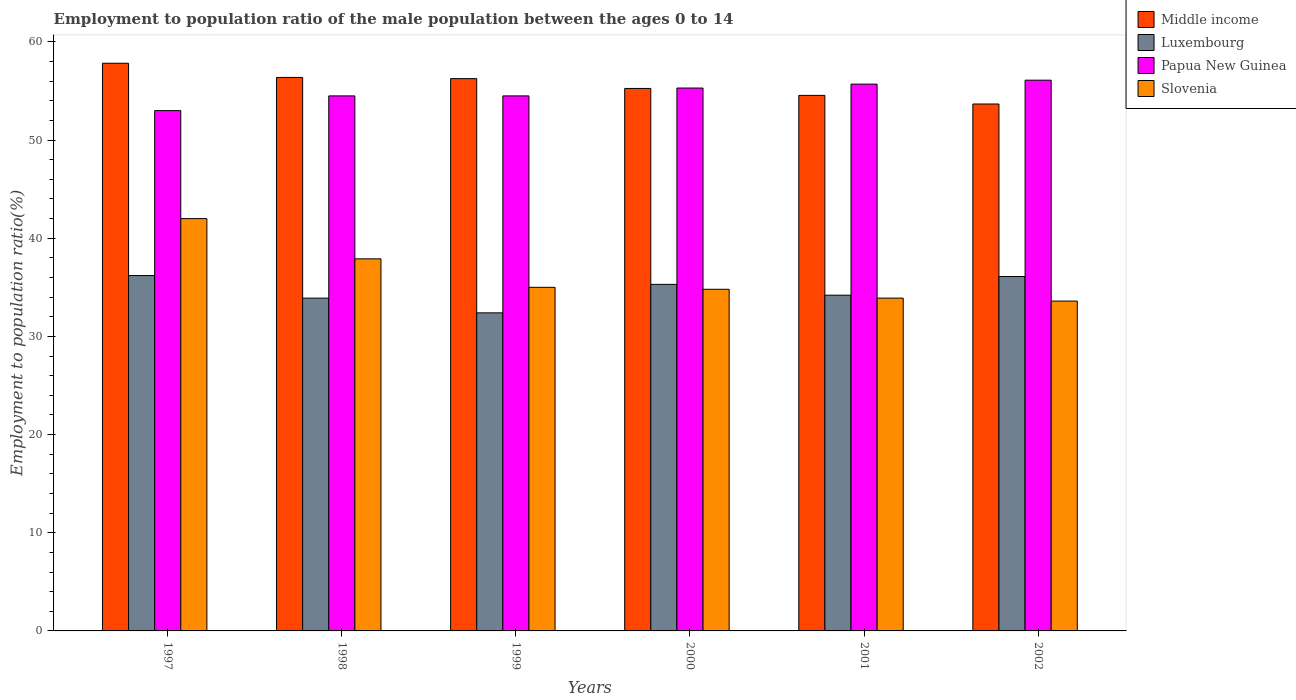How many different coloured bars are there?
Give a very brief answer. 4. How many groups of bars are there?
Make the answer very short. 6. Are the number of bars on each tick of the X-axis equal?
Give a very brief answer. Yes. What is the label of the 3rd group of bars from the left?
Offer a terse response. 1999. In how many cases, is the number of bars for a given year not equal to the number of legend labels?
Keep it short and to the point. 0. What is the employment to population ratio in Middle income in 2002?
Offer a very short reply. 53.67. Across all years, what is the minimum employment to population ratio in Papua New Guinea?
Your answer should be compact. 53. In which year was the employment to population ratio in Luxembourg maximum?
Ensure brevity in your answer.  1997. In which year was the employment to population ratio in Luxembourg minimum?
Keep it short and to the point. 1999. What is the total employment to population ratio in Slovenia in the graph?
Provide a short and direct response. 217.2. What is the difference between the employment to population ratio in Papua New Guinea in 1999 and that in 2000?
Make the answer very short. -0.8. What is the difference between the employment to population ratio in Middle income in 1998 and the employment to population ratio in Papua New Guinea in 2001?
Offer a very short reply. 0.68. What is the average employment to population ratio in Luxembourg per year?
Give a very brief answer. 34.68. In the year 1999, what is the difference between the employment to population ratio in Luxembourg and employment to population ratio in Papua New Guinea?
Make the answer very short. -22.1. What is the ratio of the employment to population ratio in Middle income in 1998 to that in 1999?
Keep it short and to the point. 1. Is the difference between the employment to population ratio in Luxembourg in 1997 and 2002 greater than the difference between the employment to population ratio in Papua New Guinea in 1997 and 2002?
Your answer should be very brief. Yes. What is the difference between the highest and the second highest employment to population ratio in Luxembourg?
Provide a succinct answer. 0.1. What is the difference between the highest and the lowest employment to population ratio in Middle income?
Offer a terse response. 4.15. In how many years, is the employment to population ratio in Slovenia greater than the average employment to population ratio in Slovenia taken over all years?
Your response must be concise. 2. Is the sum of the employment to population ratio in Middle income in 1997 and 2001 greater than the maximum employment to population ratio in Slovenia across all years?
Your answer should be very brief. Yes. What does the 3rd bar from the left in 2000 represents?
Ensure brevity in your answer.  Papua New Guinea. What does the 3rd bar from the right in 2002 represents?
Make the answer very short. Luxembourg. Is it the case that in every year, the sum of the employment to population ratio in Middle income and employment to population ratio in Papua New Guinea is greater than the employment to population ratio in Slovenia?
Provide a short and direct response. Yes. Are all the bars in the graph horizontal?
Your response must be concise. No. How many years are there in the graph?
Offer a very short reply. 6. Are the values on the major ticks of Y-axis written in scientific E-notation?
Your response must be concise. No. Does the graph contain grids?
Provide a succinct answer. No. Where does the legend appear in the graph?
Offer a terse response. Top right. What is the title of the graph?
Ensure brevity in your answer.  Employment to population ratio of the male population between the ages 0 to 14. What is the label or title of the X-axis?
Your response must be concise. Years. What is the Employment to population ratio(%) in Middle income in 1997?
Offer a very short reply. 57.82. What is the Employment to population ratio(%) of Luxembourg in 1997?
Keep it short and to the point. 36.2. What is the Employment to population ratio(%) of Papua New Guinea in 1997?
Your answer should be compact. 53. What is the Employment to population ratio(%) of Slovenia in 1997?
Offer a terse response. 42. What is the Employment to population ratio(%) of Middle income in 1998?
Your response must be concise. 56.38. What is the Employment to population ratio(%) in Luxembourg in 1998?
Your response must be concise. 33.9. What is the Employment to population ratio(%) in Papua New Guinea in 1998?
Provide a short and direct response. 54.5. What is the Employment to population ratio(%) of Slovenia in 1998?
Offer a very short reply. 37.9. What is the Employment to population ratio(%) of Middle income in 1999?
Offer a very short reply. 56.26. What is the Employment to population ratio(%) in Luxembourg in 1999?
Your answer should be compact. 32.4. What is the Employment to population ratio(%) in Papua New Guinea in 1999?
Offer a very short reply. 54.5. What is the Employment to population ratio(%) in Middle income in 2000?
Offer a terse response. 55.26. What is the Employment to population ratio(%) in Luxembourg in 2000?
Ensure brevity in your answer.  35.3. What is the Employment to population ratio(%) of Papua New Guinea in 2000?
Your answer should be very brief. 55.3. What is the Employment to population ratio(%) of Slovenia in 2000?
Make the answer very short. 34.8. What is the Employment to population ratio(%) in Middle income in 2001?
Your response must be concise. 54.55. What is the Employment to population ratio(%) in Luxembourg in 2001?
Provide a succinct answer. 34.2. What is the Employment to population ratio(%) of Papua New Guinea in 2001?
Your response must be concise. 55.7. What is the Employment to population ratio(%) of Slovenia in 2001?
Provide a succinct answer. 33.9. What is the Employment to population ratio(%) of Middle income in 2002?
Your answer should be very brief. 53.67. What is the Employment to population ratio(%) of Luxembourg in 2002?
Your response must be concise. 36.1. What is the Employment to population ratio(%) in Papua New Guinea in 2002?
Ensure brevity in your answer.  56.1. What is the Employment to population ratio(%) in Slovenia in 2002?
Keep it short and to the point. 33.6. Across all years, what is the maximum Employment to population ratio(%) in Middle income?
Keep it short and to the point. 57.82. Across all years, what is the maximum Employment to population ratio(%) of Luxembourg?
Give a very brief answer. 36.2. Across all years, what is the maximum Employment to population ratio(%) in Papua New Guinea?
Provide a short and direct response. 56.1. Across all years, what is the minimum Employment to population ratio(%) in Middle income?
Offer a terse response. 53.67. Across all years, what is the minimum Employment to population ratio(%) of Luxembourg?
Give a very brief answer. 32.4. Across all years, what is the minimum Employment to population ratio(%) of Papua New Guinea?
Make the answer very short. 53. Across all years, what is the minimum Employment to population ratio(%) in Slovenia?
Make the answer very short. 33.6. What is the total Employment to population ratio(%) in Middle income in the graph?
Provide a succinct answer. 333.94. What is the total Employment to population ratio(%) of Luxembourg in the graph?
Offer a terse response. 208.1. What is the total Employment to population ratio(%) in Papua New Guinea in the graph?
Make the answer very short. 329.1. What is the total Employment to population ratio(%) of Slovenia in the graph?
Offer a very short reply. 217.2. What is the difference between the Employment to population ratio(%) of Middle income in 1997 and that in 1998?
Your response must be concise. 1.45. What is the difference between the Employment to population ratio(%) in Luxembourg in 1997 and that in 1998?
Offer a terse response. 2.3. What is the difference between the Employment to population ratio(%) of Papua New Guinea in 1997 and that in 1998?
Give a very brief answer. -1.5. What is the difference between the Employment to population ratio(%) in Slovenia in 1997 and that in 1998?
Your answer should be compact. 4.1. What is the difference between the Employment to population ratio(%) of Middle income in 1997 and that in 1999?
Give a very brief answer. 1.57. What is the difference between the Employment to population ratio(%) of Luxembourg in 1997 and that in 1999?
Give a very brief answer. 3.8. What is the difference between the Employment to population ratio(%) of Papua New Guinea in 1997 and that in 1999?
Keep it short and to the point. -1.5. What is the difference between the Employment to population ratio(%) in Middle income in 1997 and that in 2000?
Your response must be concise. 2.57. What is the difference between the Employment to population ratio(%) in Luxembourg in 1997 and that in 2000?
Offer a very short reply. 0.9. What is the difference between the Employment to population ratio(%) of Papua New Guinea in 1997 and that in 2000?
Give a very brief answer. -2.3. What is the difference between the Employment to population ratio(%) of Slovenia in 1997 and that in 2000?
Your response must be concise. 7.2. What is the difference between the Employment to population ratio(%) of Middle income in 1997 and that in 2001?
Your response must be concise. 3.27. What is the difference between the Employment to population ratio(%) of Luxembourg in 1997 and that in 2001?
Provide a short and direct response. 2. What is the difference between the Employment to population ratio(%) of Papua New Guinea in 1997 and that in 2001?
Keep it short and to the point. -2.7. What is the difference between the Employment to population ratio(%) of Slovenia in 1997 and that in 2001?
Ensure brevity in your answer.  8.1. What is the difference between the Employment to population ratio(%) of Middle income in 1997 and that in 2002?
Your response must be concise. 4.15. What is the difference between the Employment to population ratio(%) of Luxembourg in 1997 and that in 2002?
Keep it short and to the point. 0.1. What is the difference between the Employment to population ratio(%) in Papua New Guinea in 1997 and that in 2002?
Your answer should be very brief. -3.1. What is the difference between the Employment to population ratio(%) in Slovenia in 1997 and that in 2002?
Give a very brief answer. 8.4. What is the difference between the Employment to population ratio(%) of Middle income in 1998 and that in 1999?
Your response must be concise. 0.12. What is the difference between the Employment to population ratio(%) in Luxembourg in 1998 and that in 1999?
Offer a very short reply. 1.5. What is the difference between the Employment to population ratio(%) of Papua New Guinea in 1998 and that in 1999?
Your response must be concise. 0. What is the difference between the Employment to population ratio(%) in Middle income in 1998 and that in 2000?
Offer a terse response. 1.12. What is the difference between the Employment to population ratio(%) in Luxembourg in 1998 and that in 2000?
Provide a succinct answer. -1.4. What is the difference between the Employment to population ratio(%) in Slovenia in 1998 and that in 2000?
Your response must be concise. 3.1. What is the difference between the Employment to population ratio(%) of Middle income in 1998 and that in 2001?
Offer a very short reply. 1.83. What is the difference between the Employment to population ratio(%) of Middle income in 1998 and that in 2002?
Provide a short and direct response. 2.71. What is the difference between the Employment to population ratio(%) in Middle income in 1999 and that in 2000?
Keep it short and to the point. 1. What is the difference between the Employment to population ratio(%) of Slovenia in 1999 and that in 2000?
Offer a very short reply. 0.2. What is the difference between the Employment to population ratio(%) of Middle income in 1999 and that in 2001?
Keep it short and to the point. 1.71. What is the difference between the Employment to population ratio(%) in Luxembourg in 1999 and that in 2001?
Ensure brevity in your answer.  -1.8. What is the difference between the Employment to population ratio(%) of Papua New Guinea in 1999 and that in 2001?
Offer a terse response. -1.2. What is the difference between the Employment to population ratio(%) in Slovenia in 1999 and that in 2001?
Offer a very short reply. 1.1. What is the difference between the Employment to population ratio(%) of Middle income in 1999 and that in 2002?
Your answer should be compact. 2.58. What is the difference between the Employment to population ratio(%) of Middle income in 2000 and that in 2001?
Your answer should be very brief. 0.71. What is the difference between the Employment to population ratio(%) of Luxembourg in 2000 and that in 2001?
Offer a very short reply. 1.1. What is the difference between the Employment to population ratio(%) in Papua New Guinea in 2000 and that in 2001?
Offer a terse response. -0.4. What is the difference between the Employment to population ratio(%) in Middle income in 2000 and that in 2002?
Provide a succinct answer. 1.59. What is the difference between the Employment to population ratio(%) of Luxembourg in 2000 and that in 2002?
Your answer should be compact. -0.8. What is the difference between the Employment to population ratio(%) of Papua New Guinea in 2000 and that in 2002?
Provide a succinct answer. -0.8. What is the difference between the Employment to population ratio(%) of Middle income in 2001 and that in 2002?
Provide a short and direct response. 0.88. What is the difference between the Employment to population ratio(%) in Slovenia in 2001 and that in 2002?
Provide a short and direct response. 0.3. What is the difference between the Employment to population ratio(%) in Middle income in 1997 and the Employment to population ratio(%) in Luxembourg in 1998?
Your answer should be very brief. 23.92. What is the difference between the Employment to population ratio(%) in Middle income in 1997 and the Employment to population ratio(%) in Papua New Guinea in 1998?
Your answer should be very brief. 3.32. What is the difference between the Employment to population ratio(%) in Middle income in 1997 and the Employment to population ratio(%) in Slovenia in 1998?
Keep it short and to the point. 19.92. What is the difference between the Employment to population ratio(%) of Luxembourg in 1997 and the Employment to population ratio(%) of Papua New Guinea in 1998?
Give a very brief answer. -18.3. What is the difference between the Employment to population ratio(%) of Luxembourg in 1997 and the Employment to population ratio(%) of Slovenia in 1998?
Your response must be concise. -1.7. What is the difference between the Employment to population ratio(%) in Papua New Guinea in 1997 and the Employment to population ratio(%) in Slovenia in 1998?
Offer a very short reply. 15.1. What is the difference between the Employment to population ratio(%) in Middle income in 1997 and the Employment to population ratio(%) in Luxembourg in 1999?
Provide a succinct answer. 25.42. What is the difference between the Employment to population ratio(%) of Middle income in 1997 and the Employment to population ratio(%) of Papua New Guinea in 1999?
Offer a terse response. 3.32. What is the difference between the Employment to population ratio(%) of Middle income in 1997 and the Employment to population ratio(%) of Slovenia in 1999?
Provide a short and direct response. 22.82. What is the difference between the Employment to population ratio(%) of Luxembourg in 1997 and the Employment to population ratio(%) of Papua New Guinea in 1999?
Your answer should be very brief. -18.3. What is the difference between the Employment to population ratio(%) of Luxembourg in 1997 and the Employment to population ratio(%) of Slovenia in 1999?
Offer a terse response. 1.2. What is the difference between the Employment to population ratio(%) of Papua New Guinea in 1997 and the Employment to population ratio(%) of Slovenia in 1999?
Your answer should be very brief. 18. What is the difference between the Employment to population ratio(%) in Middle income in 1997 and the Employment to population ratio(%) in Luxembourg in 2000?
Offer a very short reply. 22.52. What is the difference between the Employment to population ratio(%) in Middle income in 1997 and the Employment to population ratio(%) in Papua New Guinea in 2000?
Provide a short and direct response. 2.52. What is the difference between the Employment to population ratio(%) in Middle income in 1997 and the Employment to population ratio(%) in Slovenia in 2000?
Make the answer very short. 23.02. What is the difference between the Employment to population ratio(%) of Luxembourg in 1997 and the Employment to population ratio(%) of Papua New Guinea in 2000?
Your response must be concise. -19.1. What is the difference between the Employment to population ratio(%) in Luxembourg in 1997 and the Employment to population ratio(%) in Slovenia in 2000?
Offer a terse response. 1.4. What is the difference between the Employment to population ratio(%) of Middle income in 1997 and the Employment to population ratio(%) of Luxembourg in 2001?
Your response must be concise. 23.62. What is the difference between the Employment to population ratio(%) of Middle income in 1997 and the Employment to population ratio(%) of Papua New Guinea in 2001?
Provide a short and direct response. 2.12. What is the difference between the Employment to population ratio(%) in Middle income in 1997 and the Employment to population ratio(%) in Slovenia in 2001?
Ensure brevity in your answer.  23.92. What is the difference between the Employment to population ratio(%) in Luxembourg in 1997 and the Employment to population ratio(%) in Papua New Guinea in 2001?
Ensure brevity in your answer.  -19.5. What is the difference between the Employment to population ratio(%) in Middle income in 1997 and the Employment to population ratio(%) in Luxembourg in 2002?
Keep it short and to the point. 21.72. What is the difference between the Employment to population ratio(%) of Middle income in 1997 and the Employment to population ratio(%) of Papua New Guinea in 2002?
Your response must be concise. 1.72. What is the difference between the Employment to population ratio(%) of Middle income in 1997 and the Employment to population ratio(%) of Slovenia in 2002?
Make the answer very short. 24.22. What is the difference between the Employment to population ratio(%) in Luxembourg in 1997 and the Employment to population ratio(%) in Papua New Guinea in 2002?
Make the answer very short. -19.9. What is the difference between the Employment to population ratio(%) in Luxembourg in 1997 and the Employment to population ratio(%) in Slovenia in 2002?
Offer a terse response. 2.6. What is the difference between the Employment to population ratio(%) in Papua New Guinea in 1997 and the Employment to population ratio(%) in Slovenia in 2002?
Your answer should be compact. 19.4. What is the difference between the Employment to population ratio(%) of Middle income in 1998 and the Employment to population ratio(%) of Luxembourg in 1999?
Ensure brevity in your answer.  23.98. What is the difference between the Employment to population ratio(%) in Middle income in 1998 and the Employment to population ratio(%) in Papua New Guinea in 1999?
Keep it short and to the point. 1.88. What is the difference between the Employment to population ratio(%) of Middle income in 1998 and the Employment to population ratio(%) of Slovenia in 1999?
Provide a succinct answer. 21.38. What is the difference between the Employment to population ratio(%) of Luxembourg in 1998 and the Employment to population ratio(%) of Papua New Guinea in 1999?
Make the answer very short. -20.6. What is the difference between the Employment to population ratio(%) of Luxembourg in 1998 and the Employment to population ratio(%) of Slovenia in 1999?
Ensure brevity in your answer.  -1.1. What is the difference between the Employment to population ratio(%) of Papua New Guinea in 1998 and the Employment to population ratio(%) of Slovenia in 1999?
Ensure brevity in your answer.  19.5. What is the difference between the Employment to population ratio(%) of Middle income in 1998 and the Employment to population ratio(%) of Luxembourg in 2000?
Provide a short and direct response. 21.08. What is the difference between the Employment to population ratio(%) in Middle income in 1998 and the Employment to population ratio(%) in Papua New Guinea in 2000?
Provide a short and direct response. 1.08. What is the difference between the Employment to population ratio(%) of Middle income in 1998 and the Employment to population ratio(%) of Slovenia in 2000?
Keep it short and to the point. 21.58. What is the difference between the Employment to population ratio(%) in Luxembourg in 1998 and the Employment to population ratio(%) in Papua New Guinea in 2000?
Provide a succinct answer. -21.4. What is the difference between the Employment to population ratio(%) of Luxembourg in 1998 and the Employment to population ratio(%) of Slovenia in 2000?
Offer a very short reply. -0.9. What is the difference between the Employment to population ratio(%) of Middle income in 1998 and the Employment to population ratio(%) of Luxembourg in 2001?
Your response must be concise. 22.18. What is the difference between the Employment to population ratio(%) of Middle income in 1998 and the Employment to population ratio(%) of Papua New Guinea in 2001?
Give a very brief answer. 0.68. What is the difference between the Employment to population ratio(%) of Middle income in 1998 and the Employment to population ratio(%) of Slovenia in 2001?
Ensure brevity in your answer.  22.48. What is the difference between the Employment to population ratio(%) in Luxembourg in 1998 and the Employment to population ratio(%) in Papua New Guinea in 2001?
Provide a short and direct response. -21.8. What is the difference between the Employment to population ratio(%) of Papua New Guinea in 1998 and the Employment to population ratio(%) of Slovenia in 2001?
Offer a very short reply. 20.6. What is the difference between the Employment to population ratio(%) of Middle income in 1998 and the Employment to population ratio(%) of Luxembourg in 2002?
Offer a terse response. 20.28. What is the difference between the Employment to population ratio(%) of Middle income in 1998 and the Employment to population ratio(%) of Papua New Guinea in 2002?
Provide a succinct answer. 0.28. What is the difference between the Employment to population ratio(%) of Middle income in 1998 and the Employment to population ratio(%) of Slovenia in 2002?
Offer a terse response. 22.78. What is the difference between the Employment to population ratio(%) in Luxembourg in 1998 and the Employment to population ratio(%) in Papua New Guinea in 2002?
Keep it short and to the point. -22.2. What is the difference between the Employment to population ratio(%) of Papua New Guinea in 1998 and the Employment to population ratio(%) of Slovenia in 2002?
Keep it short and to the point. 20.9. What is the difference between the Employment to population ratio(%) in Middle income in 1999 and the Employment to population ratio(%) in Luxembourg in 2000?
Ensure brevity in your answer.  20.96. What is the difference between the Employment to population ratio(%) of Middle income in 1999 and the Employment to population ratio(%) of Papua New Guinea in 2000?
Provide a succinct answer. 0.96. What is the difference between the Employment to population ratio(%) in Middle income in 1999 and the Employment to population ratio(%) in Slovenia in 2000?
Offer a very short reply. 21.46. What is the difference between the Employment to population ratio(%) in Luxembourg in 1999 and the Employment to population ratio(%) in Papua New Guinea in 2000?
Ensure brevity in your answer.  -22.9. What is the difference between the Employment to population ratio(%) in Luxembourg in 1999 and the Employment to population ratio(%) in Slovenia in 2000?
Offer a very short reply. -2.4. What is the difference between the Employment to population ratio(%) of Middle income in 1999 and the Employment to population ratio(%) of Luxembourg in 2001?
Your answer should be compact. 22.06. What is the difference between the Employment to population ratio(%) of Middle income in 1999 and the Employment to population ratio(%) of Papua New Guinea in 2001?
Make the answer very short. 0.56. What is the difference between the Employment to population ratio(%) in Middle income in 1999 and the Employment to population ratio(%) in Slovenia in 2001?
Offer a very short reply. 22.36. What is the difference between the Employment to population ratio(%) in Luxembourg in 1999 and the Employment to population ratio(%) in Papua New Guinea in 2001?
Offer a terse response. -23.3. What is the difference between the Employment to population ratio(%) of Luxembourg in 1999 and the Employment to population ratio(%) of Slovenia in 2001?
Offer a terse response. -1.5. What is the difference between the Employment to population ratio(%) of Papua New Guinea in 1999 and the Employment to population ratio(%) of Slovenia in 2001?
Your response must be concise. 20.6. What is the difference between the Employment to population ratio(%) in Middle income in 1999 and the Employment to population ratio(%) in Luxembourg in 2002?
Give a very brief answer. 20.16. What is the difference between the Employment to population ratio(%) in Middle income in 1999 and the Employment to population ratio(%) in Papua New Guinea in 2002?
Provide a short and direct response. 0.16. What is the difference between the Employment to population ratio(%) in Middle income in 1999 and the Employment to population ratio(%) in Slovenia in 2002?
Your answer should be compact. 22.66. What is the difference between the Employment to population ratio(%) in Luxembourg in 1999 and the Employment to population ratio(%) in Papua New Guinea in 2002?
Give a very brief answer. -23.7. What is the difference between the Employment to population ratio(%) in Papua New Guinea in 1999 and the Employment to population ratio(%) in Slovenia in 2002?
Make the answer very short. 20.9. What is the difference between the Employment to population ratio(%) of Middle income in 2000 and the Employment to population ratio(%) of Luxembourg in 2001?
Provide a succinct answer. 21.06. What is the difference between the Employment to population ratio(%) in Middle income in 2000 and the Employment to population ratio(%) in Papua New Guinea in 2001?
Ensure brevity in your answer.  -0.44. What is the difference between the Employment to population ratio(%) in Middle income in 2000 and the Employment to population ratio(%) in Slovenia in 2001?
Your answer should be compact. 21.36. What is the difference between the Employment to population ratio(%) of Luxembourg in 2000 and the Employment to population ratio(%) of Papua New Guinea in 2001?
Your answer should be very brief. -20.4. What is the difference between the Employment to population ratio(%) in Papua New Guinea in 2000 and the Employment to population ratio(%) in Slovenia in 2001?
Offer a terse response. 21.4. What is the difference between the Employment to population ratio(%) of Middle income in 2000 and the Employment to population ratio(%) of Luxembourg in 2002?
Give a very brief answer. 19.16. What is the difference between the Employment to population ratio(%) of Middle income in 2000 and the Employment to population ratio(%) of Papua New Guinea in 2002?
Your response must be concise. -0.84. What is the difference between the Employment to population ratio(%) of Middle income in 2000 and the Employment to population ratio(%) of Slovenia in 2002?
Make the answer very short. 21.66. What is the difference between the Employment to population ratio(%) in Luxembourg in 2000 and the Employment to population ratio(%) in Papua New Guinea in 2002?
Give a very brief answer. -20.8. What is the difference between the Employment to population ratio(%) of Papua New Guinea in 2000 and the Employment to population ratio(%) of Slovenia in 2002?
Provide a succinct answer. 21.7. What is the difference between the Employment to population ratio(%) of Middle income in 2001 and the Employment to population ratio(%) of Luxembourg in 2002?
Provide a short and direct response. 18.45. What is the difference between the Employment to population ratio(%) of Middle income in 2001 and the Employment to population ratio(%) of Papua New Guinea in 2002?
Your answer should be very brief. -1.55. What is the difference between the Employment to population ratio(%) of Middle income in 2001 and the Employment to population ratio(%) of Slovenia in 2002?
Your response must be concise. 20.95. What is the difference between the Employment to population ratio(%) of Luxembourg in 2001 and the Employment to population ratio(%) of Papua New Guinea in 2002?
Offer a very short reply. -21.9. What is the difference between the Employment to population ratio(%) of Luxembourg in 2001 and the Employment to population ratio(%) of Slovenia in 2002?
Ensure brevity in your answer.  0.6. What is the difference between the Employment to population ratio(%) of Papua New Guinea in 2001 and the Employment to population ratio(%) of Slovenia in 2002?
Your response must be concise. 22.1. What is the average Employment to population ratio(%) of Middle income per year?
Provide a succinct answer. 55.66. What is the average Employment to population ratio(%) of Luxembourg per year?
Make the answer very short. 34.68. What is the average Employment to population ratio(%) in Papua New Guinea per year?
Ensure brevity in your answer.  54.85. What is the average Employment to population ratio(%) in Slovenia per year?
Keep it short and to the point. 36.2. In the year 1997, what is the difference between the Employment to population ratio(%) of Middle income and Employment to population ratio(%) of Luxembourg?
Provide a short and direct response. 21.62. In the year 1997, what is the difference between the Employment to population ratio(%) of Middle income and Employment to population ratio(%) of Papua New Guinea?
Offer a terse response. 4.82. In the year 1997, what is the difference between the Employment to population ratio(%) of Middle income and Employment to population ratio(%) of Slovenia?
Keep it short and to the point. 15.82. In the year 1997, what is the difference between the Employment to population ratio(%) of Luxembourg and Employment to population ratio(%) of Papua New Guinea?
Offer a very short reply. -16.8. In the year 1997, what is the difference between the Employment to population ratio(%) in Papua New Guinea and Employment to population ratio(%) in Slovenia?
Make the answer very short. 11. In the year 1998, what is the difference between the Employment to population ratio(%) in Middle income and Employment to population ratio(%) in Luxembourg?
Ensure brevity in your answer.  22.48. In the year 1998, what is the difference between the Employment to population ratio(%) of Middle income and Employment to population ratio(%) of Papua New Guinea?
Your response must be concise. 1.88. In the year 1998, what is the difference between the Employment to population ratio(%) of Middle income and Employment to population ratio(%) of Slovenia?
Keep it short and to the point. 18.48. In the year 1998, what is the difference between the Employment to population ratio(%) of Luxembourg and Employment to population ratio(%) of Papua New Guinea?
Keep it short and to the point. -20.6. In the year 1998, what is the difference between the Employment to population ratio(%) in Luxembourg and Employment to population ratio(%) in Slovenia?
Ensure brevity in your answer.  -4. In the year 1999, what is the difference between the Employment to population ratio(%) in Middle income and Employment to population ratio(%) in Luxembourg?
Keep it short and to the point. 23.86. In the year 1999, what is the difference between the Employment to population ratio(%) in Middle income and Employment to population ratio(%) in Papua New Guinea?
Make the answer very short. 1.76. In the year 1999, what is the difference between the Employment to population ratio(%) of Middle income and Employment to population ratio(%) of Slovenia?
Provide a short and direct response. 21.26. In the year 1999, what is the difference between the Employment to population ratio(%) of Luxembourg and Employment to population ratio(%) of Papua New Guinea?
Your answer should be compact. -22.1. In the year 1999, what is the difference between the Employment to population ratio(%) of Papua New Guinea and Employment to population ratio(%) of Slovenia?
Make the answer very short. 19.5. In the year 2000, what is the difference between the Employment to population ratio(%) of Middle income and Employment to population ratio(%) of Luxembourg?
Offer a very short reply. 19.96. In the year 2000, what is the difference between the Employment to population ratio(%) of Middle income and Employment to population ratio(%) of Papua New Guinea?
Your answer should be very brief. -0.04. In the year 2000, what is the difference between the Employment to population ratio(%) of Middle income and Employment to population ratio(%) of Slovenia?
Keep it short and to the point. 20.46. In the year 2000, what is the difference between the Employment to population ratio(%) in Luxembourg and Employment to population ratio(%) in Papua New Guinea?
Keep it short and to the point. -20. In the year 2000, what is the difference between the Employment to population ratio(%) of Papua New Guinea and Employment to population ratio(%) of Slovenia?
Keep it short and to the point. 20.5. In the year 2001, what is the difference between the Employment to population ratio(%) in Middle income and Employment to population ratio(%) in Luxembourg?
Give a very brief answer. 20.35. In the year 2001, what is the difference between the Employment to population ratio(%) of Middle income and Employment to population ratio(%) of Papua New Guinea?
Give a very brief answer. -1.15. In the year 2001, what is the difference between the Employment to population ratio(%) of Middle income and Employment to population ratio(%) of Slovenia?
Provide a succinct answer. 20.65. In the year 2001, what is the difference between the Employment to population ratio(%) of Luxembourg and Employment to population ratio(%) of Papua New Guinea?
Provide a short and direct response. -21.5. In the year 2001, what is the difference between the Employment to population ratio(%) of Papua New Guinea and Employment to population ratio(%) of Slovenia?
Your answer should be compact. 21.8. In the year 2002, what is the difference between the Employment to population ratio(%) in Middle income and Employment to population ratio(%) in Luxembourg?
Make the answer very short. 17.57. In the year 2002, what is the difference between the Employment to population ratio(%) in Middle income and Employment to population ratio(%) in Papua New Guinea?
Provide a succinct answer. -2.43. In the year 2002, what is the difference between the Employment to population ratio(%) of Middle income and Employment to population ratio(%) of Slovenia?
Your answer should be very brief. 20.07. In the year 2002, what is the difference between the Employment to population ratio(%) of Luxembourg and Employment to population ratio(%) of Papua New Guinea?
Your answer should be very brief. -20. In the year 2002, what is the difference between the Employment to population ratio(%) in Luxembourg and Employment to population ratio(%) in Slovenia?
Offer a terse response. 2.5. In the year 2002, what is the difference between the Employment to population ratio(%) in Papua New Guinea and Employment to population ratio(%) in Slovenia?
Offer a terse response. 22.5. What is the ratio of the Employment to population ratio(%) in Middle income in 1997 to that in 1998?
Offer a very short reply. 1.03. What is the ratio of the Employment to population ratio(%) in Luxembourg in 1997 to that in 1998?
Offer a very short reply. 1.07. What is the ratio of the Employment to population ratio(%) of Papua New Guinea in 1997 to that in 1998?
Your response must be concise. 0.97. What is the ratio of the Employment to population ratio(%) of Slovenia in 1997 to that in 1998?
Your response must be concise. 1.11. What is the ratio of the Employment to population ratio(%) in Middle income in 1997 to that in 1999?
Provide a succinct answer. 1.03. What is the ratio of the Employment to population ratio(%) of Luxembourg in 1997 to that in 1999?
Your response must be concise. 1.12. What is the ratio of the Employment to population ratio(%) of Papua New Guinea in 1997 to that in 1999?
Provide a short and direct response. 0.97. What is the ratio of the Employment to population ratio(%) in Slovenia in 1997 to that in 1999?
Give a very brief answer. 1.2. What is the ratio of the Employment to population ratio(%) in Middle income in 1997 to that in 2000?
Make the answer very short. 1.05. What is the ratio of the Employment to population ratio(%) in Luxembourg in 1997 to that in 2000?
Provide a short and direct response. 1.03. What is the ratio of the Employment to population ratio(%) of Papua New Guinea in 1997 to that in 2000?
Make the answer very short. 0.96. What is the ratio of the Employment to population ratio(%) in Slovenia in 1997 to that in 2000?
Provide a succinct answer. 1.21. What is the ratio of the Employment to population ratio(%) of Middle income in 1997 to that in 2001?
Provide a short and direct response. 1.06. What is the ratio of the Employment to population ratio(%) in Luxembourg in 1997 to that in 2001?
Offer a very short reply. 1.06. What is the ratio of the Employment to population ratio(%) in Papua New Guinea in 1997 to that in 2001?
Ensure brevity in your answer.  0.95. What is the ratio of the Employment to population ratio(%) in Slovenia in 1997 to that in 2001?
Your response must be concise. 1.24. What is the ratio of the Employment to population ratio(%) in Middle income in 1997 to that in 2002?
Your answer should be very brief. 1.08. What is the ratio of the Employment to population ratio(%) of Papua New Guinea in 1997 to that in 2002?
Ensure brevity in your answer.  0.94. What is the ratio of the Employment to population ratio(%) in Luxembourg in 1998 to that in 1999?
Make the answer very short. 1.05. What is the ratio of the Employment to population ratio(%) of Slovenia in 1998 to that in 1999?
Your response must be concise. 1.08. What is the ratio of the Employment to population ratio(%) in Middle income in 1998 to that in 2000?
Ensure brevity in your answer.  1.02. What is the ratio of the Employment to population ratio(%) in Luxembourg in 1998 to that in 2000?
Provide a succinct answer. 0.96. What is the ratio of the Employment to population ratio(%) of Papua New Guinea in 1998 to that in 2000?
Provide a short and direct response. 0.99. What is the ratio of the Employment to population ratio(%) in Slovenia in 1998 to that in 2000?
Your answer should be compact. 1.09. What is the ratio of the Employment to population ratio(%) of Middle income in 1998 to that in 2001?
Ensure brevity in your answer.  1.03. What is the ratio of the Employment to population ratio(%) of Papua New Guinea in 1998 to that in 2001?
Your response must be concise. 0.98. What is the ratio of the Employment to population ratio(%) of Slovenia in 1998 to that in 2001?
Offer a terse response. 1.12. What is the ratio of the Employment to population ratio(%) of Middle income in 1998 to that in 2002?
Offer a very short reply. 1.05. What is the ratio of the Employment to population ratio(%) in Luxembourg in 1998 to that in 2002?
Offer a terse response. 0.94. What is the ratio of the Employment to population ratio(%) of Papua New Guinea in 1998 to that in 2002?
Your answer should be compact. 0.97. What is the ratio of the Employment to population ratio(%) of Slovenia in 1998 to that in 2002?
Provide a short and direct response. 1.13. What is the ratio of the Employment to population ratio(%) of Middle income in 1999 to that in 2000?
Give a very brief answer. 1.02. What is the ratio of the Employment to population ratio(%) of Luxembourg in 1999 to that in 2000?
Keep it short and to the point. 0.92. What is the ratio of the Employment to population ratio(%) in Papua New Guinea in 1999 to that in 2000?
Ensure brevity in your answer.  0.99. What is the ratio of the Employment to population ratio(%) in Slovenia in 1999 to that in 2000?
Your response must be concise. 1.01. What is the ratio of the Employment to population ratio(%) of Middle income in 1999 to that in 2001?
Your answer should be compact. 1.03. What is the ratio of the Employment to population ratio(%) of Papua New Guinea in 1999 to that in 2001?
Offer a very short reply. 0.98. What is the ratio of the Employment to population ratio(%) of Slovenia in 1999 to that in 2001?
Your answer should be very brief. 1.03. What is the ratio of the Employment to population ratio(%) in Middle income in 1999 to that in 2002?
Keep it short and to the point. 1.05. What is the ratio of the Employment to population ratio(%) of Luxembourg in 1999 to that in 2002?
Offer a very short reply. 0.9. What is the ratio of the Employment to population ratio(%) in Papua New Guinea in 1999 to that in 2002?
Give a very brief answer. 0.97. What is the ratio of the Employment to population ratio(%) of Slovenia in 1999 to that in 2002?
Ensure brevity in your answer.  1.04. What is the ratio of the Employment to population ratio(%) of Luxembourg in 2000 to that in 2001?
Provide a short and direct response. 1.03. What is the ratio of the Employment to population ratio(%) of Slovenia in 2000 to that in 2001?
Offer a terse response. 1.03. What is the ratio of the Employment to population ratio(%) of Middle income in 2000 to that in 2002?
Make the answer very short. 1.03. What is the ratio of the Employment to population ratio(%) in Luxembourg in 2000 to that in 2002?
Your response must be concise. 0.98. What is the ratio of the Employment to population ratio(%) of Papua New Guinea in 2000 to that in 2002?
Give a very brief answer. 0.99. What is the ratio of the Employment to population ratio(%) in Slovenia in 2000 to that in 2002?
Make the answer very short. 1.04. What is the ratio of the Employment to population ratio(%) in Middle income in 2001 to that in 2002?
Your response must be concise. 1.02. What is the ratio of the Employment to population ratio(%) of Slovenia in 2001 to that in 2002?
Offer a very short reply. 1.01. What is the difference between the highest and the second highest Employment to population ratio(%) of Middle income?
Ensure brevity in your answer.  1.45. What is the difference between the highest and the second highest Employment to population ratio(%) of Slovenia?
Your answer should be very brief. 4.1. What is the difference between the highest and the lowest Employment to population ratio(%) in Middle income?
Offer a terse response. 4.15. What is the difference between the highest and the lowest Employment to population ratio(%) in Luxembourg?
Offer a terse response. 3.8. What is the difference between the highest and the lowest Employment to population ratio(%) of Papua New Guinea?
Provide a succinct answer. 3.1. 